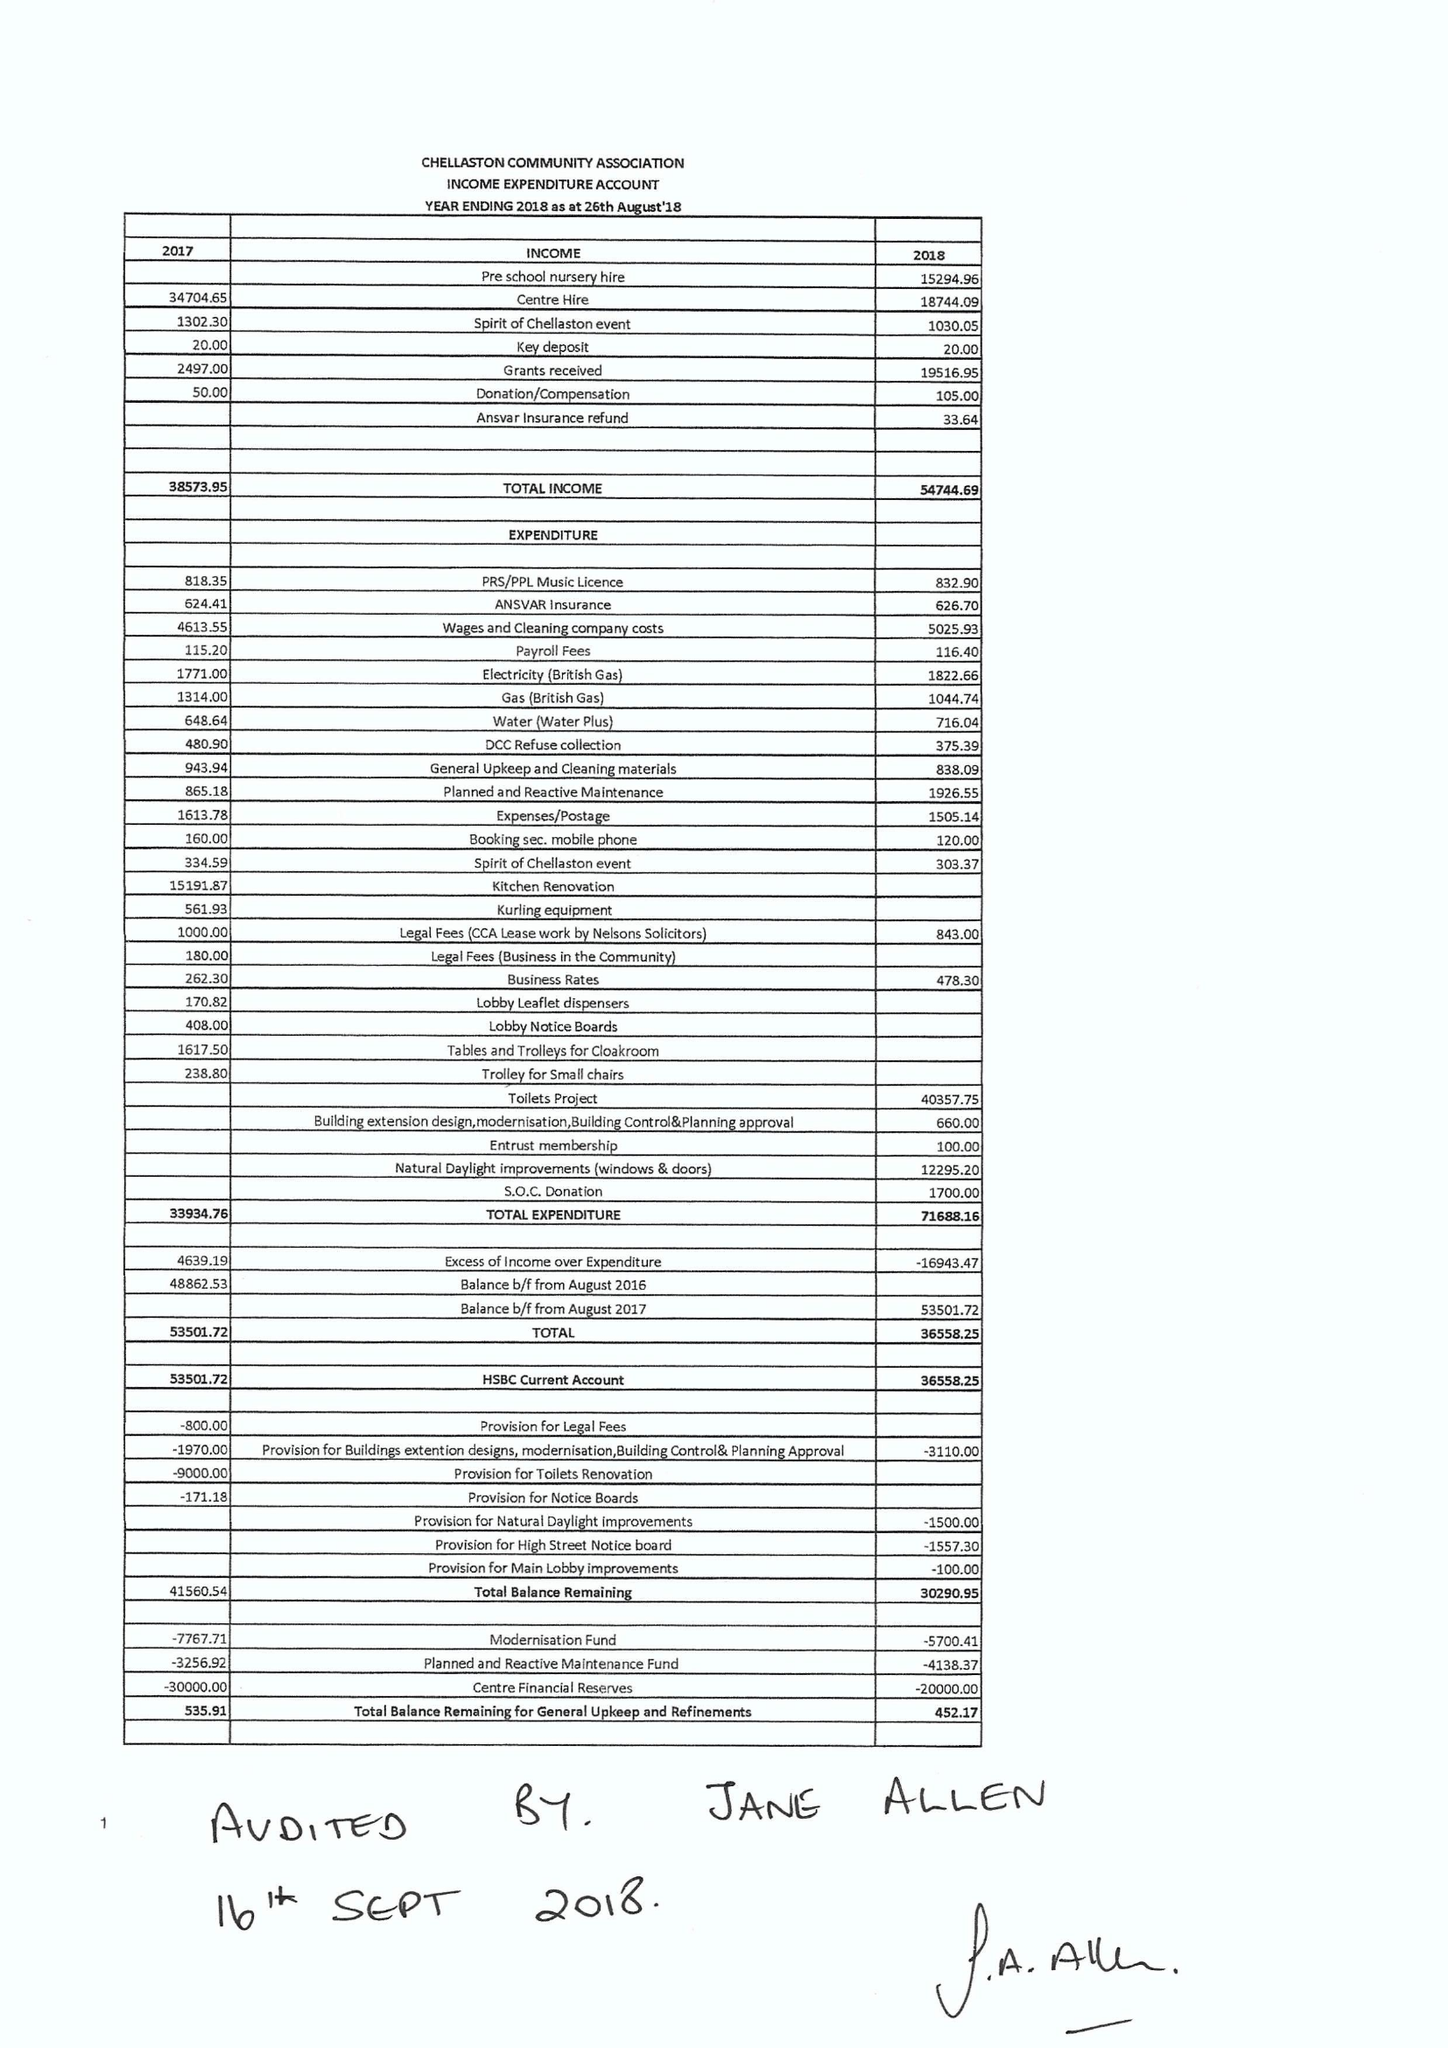What is the value for the address__postcode?
Answer the question using a single word or phrase. DE73 5QA 